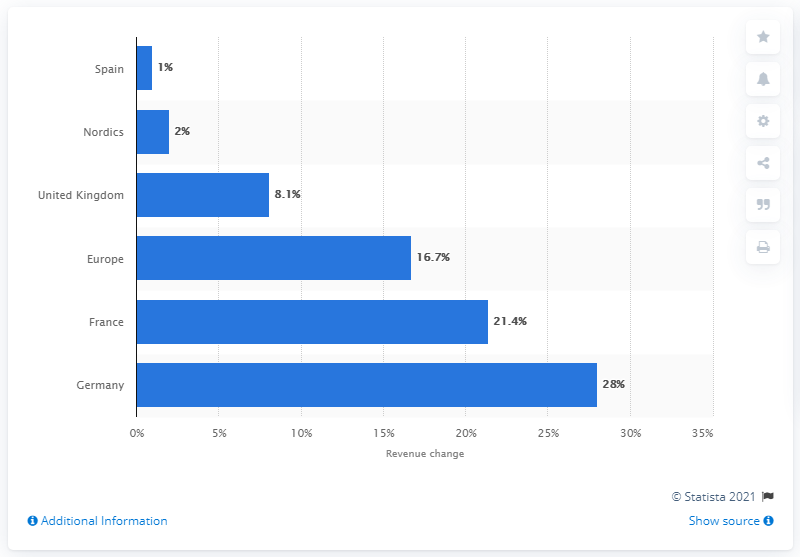Specify some key components in this picture. France was ranked as the second largest contributor to online fashion retail revenue from 2015 to 2016. According to recent data, Germany has experienced the largest increase in online fashion retail revenue, making it the top country in this regard. 